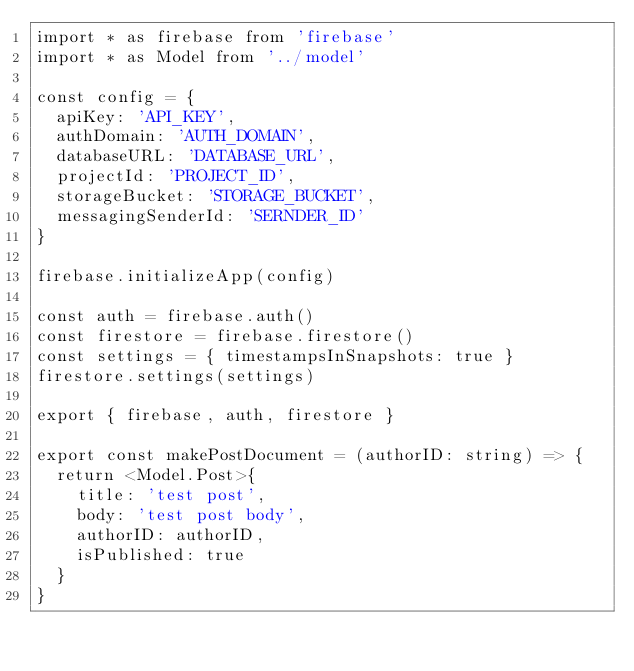<code> <loc_0><loc_0><loc_500><loc_500><_TypeScript_>import * as firebase from 'firebase'
import * as Model from '../model'

const config = {
  apiKey: 'API_KEY',
  authDomain: 'AUTH_DOMAIN',
  databaseURL: 'DATABASE_URL',
  projectId: 'PROJECT_ID',
  storageBucket: 'STORAGE_BUCKET',
  messagingSenderId: 'SERNDER_ID'
}

firebase.initializeApp(config)

const auth = firebase.auth()
const firestore = firebase.firestore()
const settings = { timestampsInSnapshots: true }
firestore.settings(settings)

export { firebase, auth, firestore }

export const makePostDocument = (authorID: string) => {
  return <Model.Post>{
    title: 'test post',
    body: 'test post body',
    authorID: authorID,
    isPublished: true
  }
}
</code> 